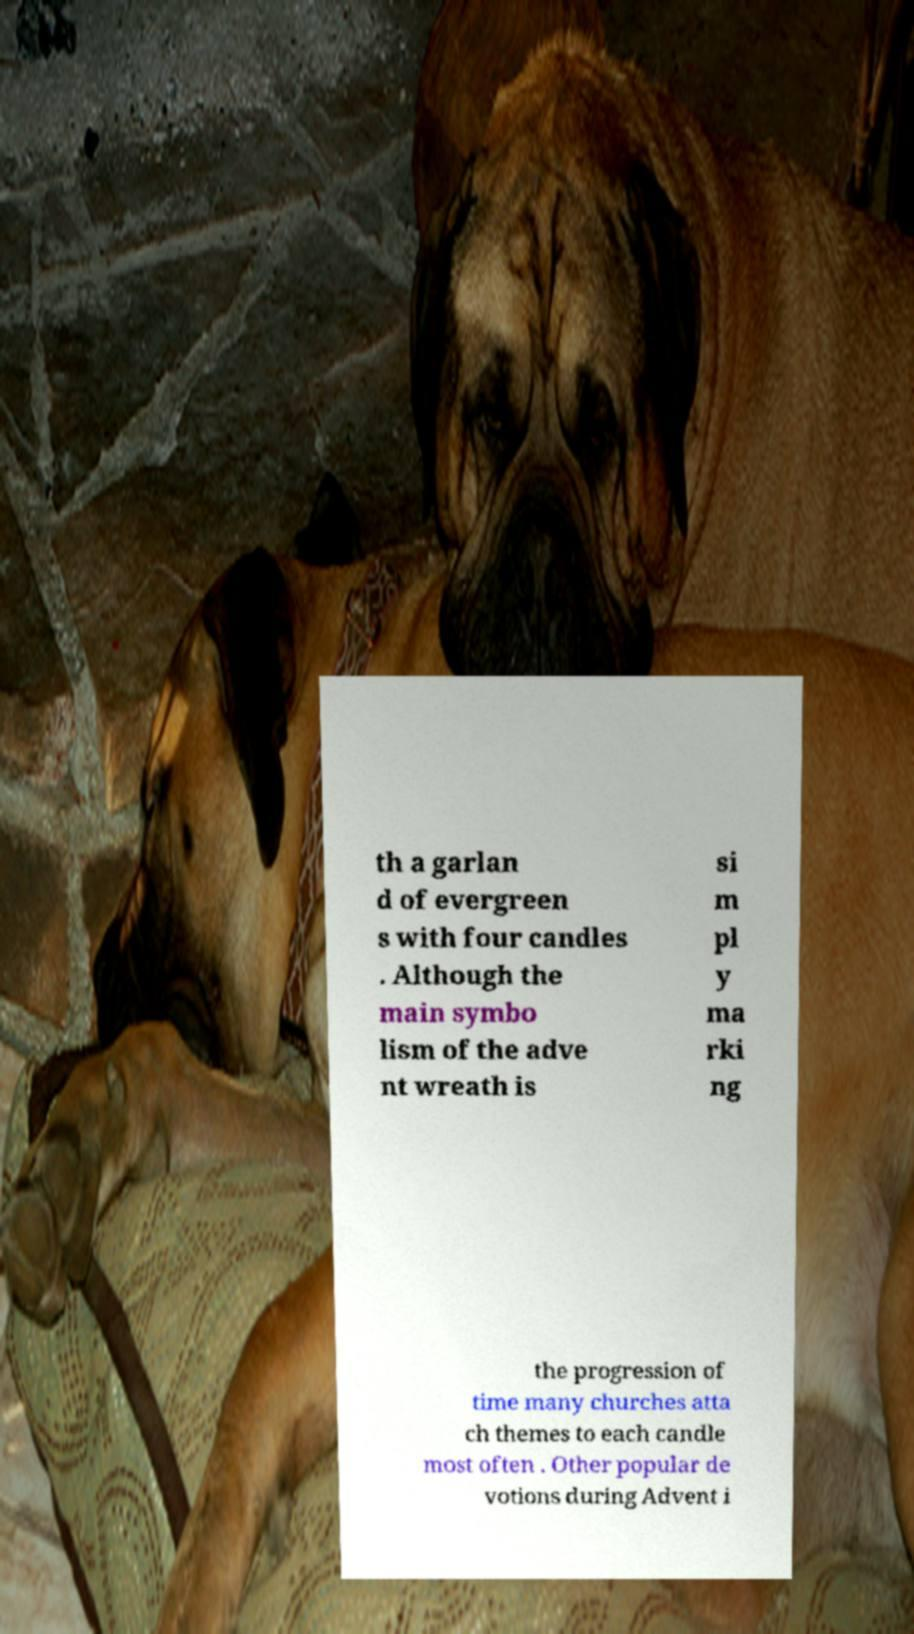Could you assist in decoding the text presented in this image and type it out clearly? th a garlan d of evergreen s with four candles . Although the main symbo lism of the adve nt wreath is si m pl y ma rki ng the progression of time many churches atta ch themes to each candle most often . Other popular de votions during Advent i 